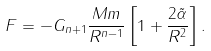Convert formula to latex. <formula><loc_0><loc_0><loc_500><loc_500>F = - G _ { n + 1 } \frac { M m } { R ^ { n - 1 } } \left [ 1 + \frac { 2 \tilde { \alpha } } { R ^ { 2 } } \right ] .</formula> 